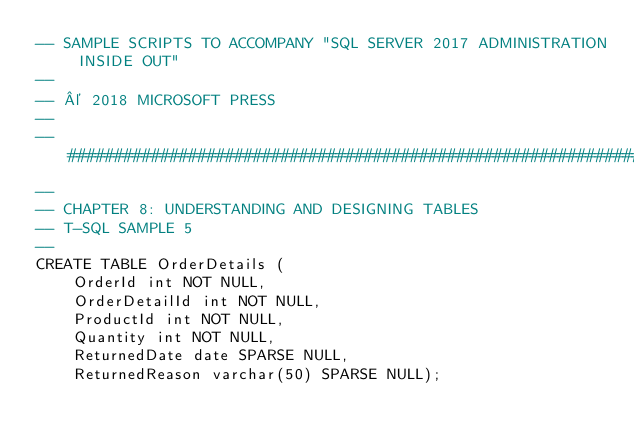Convert code to text. <code><loc_0><loc_0><loc_500><loc_500><_SQL_>-- SAMPLE SCRIPTS TO ACCOMPANY "SQL SERVER 2017 ADMINISTRATION INSIDE OUT"
--
-- © 2018 MICROSOFT PRESS
--
--##############################################################################
--
-- CHAPTER 8: UNDERSTANDING AND DESIGNING TABLES
-- T-SQL SAMPLE 5
--
CREATE TABLE OrderDetails (
    OrderId int NOT NULL,
    OrderDetailId int NOT NULL,
    ProductId int NOT NULL,
    Quantity int NOT NULL,
    ReturnedDate date SPARSE NULL,
    ReturnedReason varchar(50) SPARSE NULL);</code> 